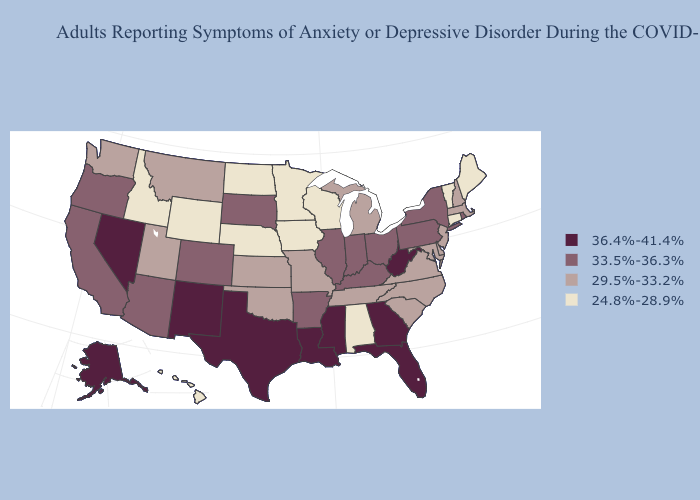What is the value of Texas?
Be succinct. 36.4%-41.4%. Does Washington have a higher value than Vermont?
Keep it brief. Yes. Name the states that have a value in the range 33.5%-36.3%?
Write a very short answer. Arizona, Arkansas, California, Colorado, Illinois, Indiana, Kentucky, New York, Ohio, Oregon, Pennsylvania, Rhode Island, South Dakota. Does Mississippi have the highest value in the South?
Concise answer only. Yes. Among the states that border Pennsylvania , which have the highest value?
Answer briefly. West Virginia. Does the map have missing data?
Answer briefly. No. What is the value of Oklahoma?
Keep it brief. 29.5%-33.2%. What is the value of Arkansas?
Short answer required. 33.5%-36.3%. What is the highest value in states that border Oregon?
Write a very short answer. 36.4%-41.4%. Which states have the lowest value in the South?
Quick response, please. Alabama. Does Minnesota have the lowest value in the USA?
Answer briefly. Yes. How many symbols are there in the legend?
Give a very brief answer. 4. What is the value of Alaska?
Be succinct. 36.4%-41.4%. Name the states that have a value in the range 36.4%-41.4%?
Short answer required. Alaska, Florida, Georgia, Louisiana, Mississippi, Nevada, New Mexico, Texas, West Virginia. Which states have the lowest value in the West?
Write a very short answer. Hawaii, Idaho, Wyoming. 